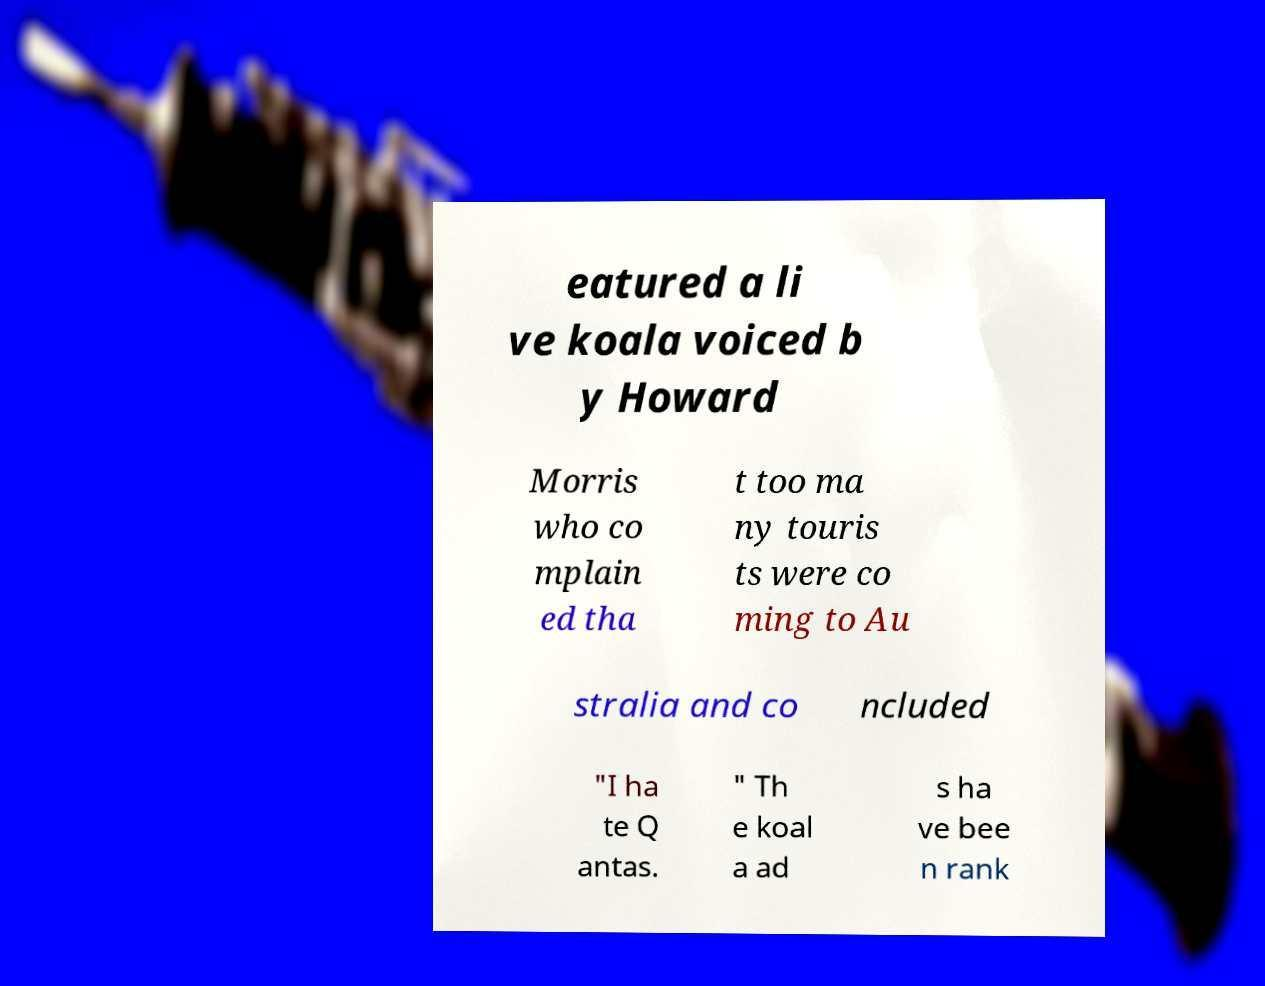For documentation purposes, I need the text within this image transcribed. Could you provide that? eatured a li ve koala voiced b y Howard Morris who co mplain ed tha t too ma ny touris ts were co ming to Au stralia and co ncluded "I ha te Q antas. " Th e koal a ad s ha ve bee n rank 